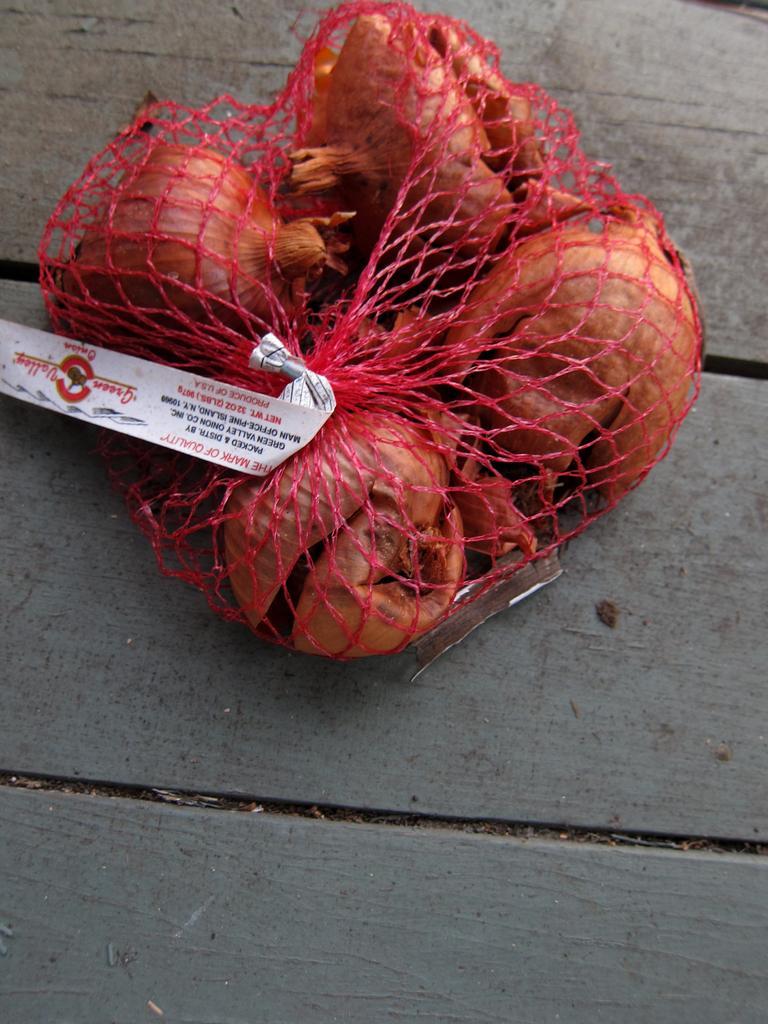Can you describe this image briefly? In this image we can see some fruits which are packed in net which is of pink color and there is a sticker attached to it which is on wooden surface. 